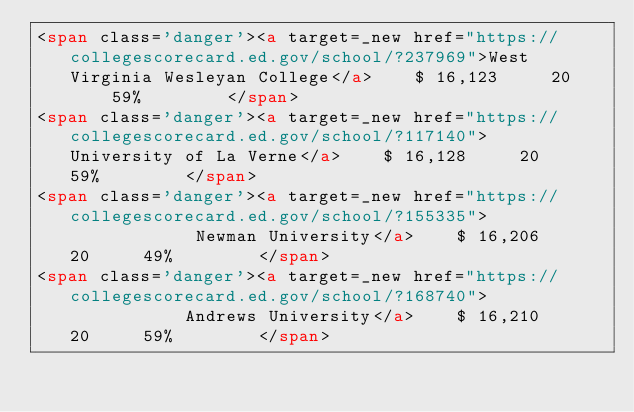Convert code to text. <code><loc_0><loc_0><loc_500><loc_500><_HTML_><span class='danger'><a target=_new href="https://collegescorecard.ed.gov/school/?237969">West Virginia Wesleyan College</a>    $ 16,123     20     59%        </span>
<span class='danger'><a target=_new href="https://collegescorecard.ed.gov/school/?117140">        University of La Verne</a>    $ 16,128     20     59%        </span>
<span class='danger'><a target=_new href="https://collegescorecard.ed.gov/school/?155335">             Newman University</a>    $ 16,206     20     49%        </span>
<span class='danger'><a target=_new href="https://collegescorecard.ed.gov/school/?168740">            Andrews University</a>    $ 16,210     20     59%        </span></code> 